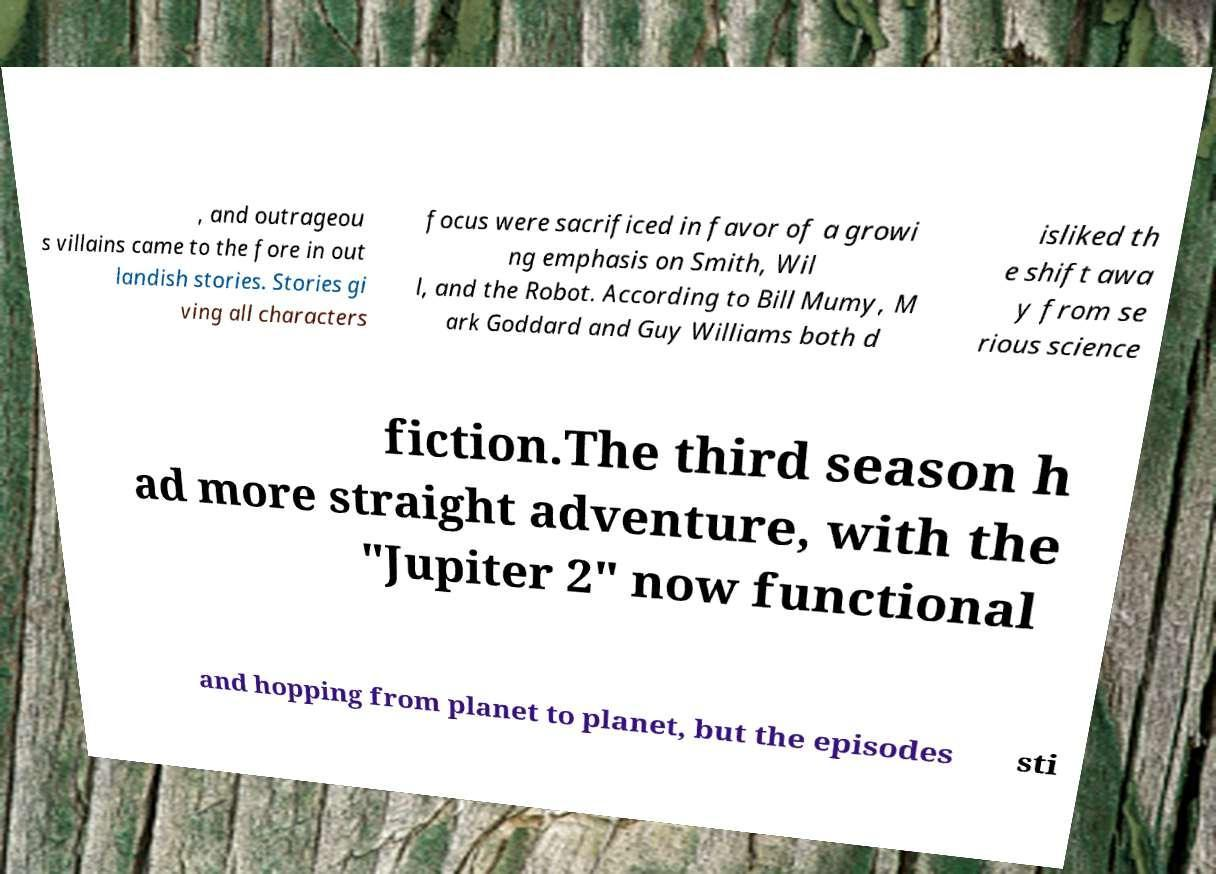Can you accurately transcribe the text from the provided image for me? , and outrageou s villains came to the fore in out landish stories. Stories gi ving all characters focus were sacrificed in favor of a growi ng emphasis on Smith, Wil l, and the Robot. According to Bill Mumy, M ark Goddard and Guy Williams both d isliked th e shift awa y from se rious science fiction.The third season h ad more straight adventure, with the "Jupiter 2" now functional and hopping from planet to planet, but the episodes sti 